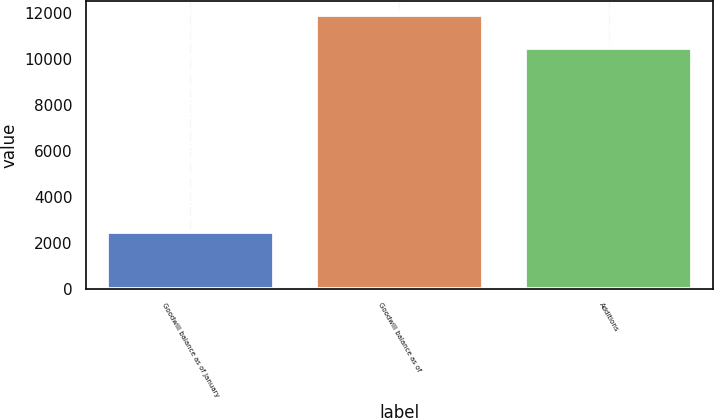Convert chart to OTSL. <chart><loc_0><loc_0><loc_500><loc_500><bar_chart><fcel>Goodwill balance as of January<fcel>Goodwill balance as of<fcel>Additions<nl><fcel>2487.14<fcel>11923.1<fcel>10484.4<nl></chart> 